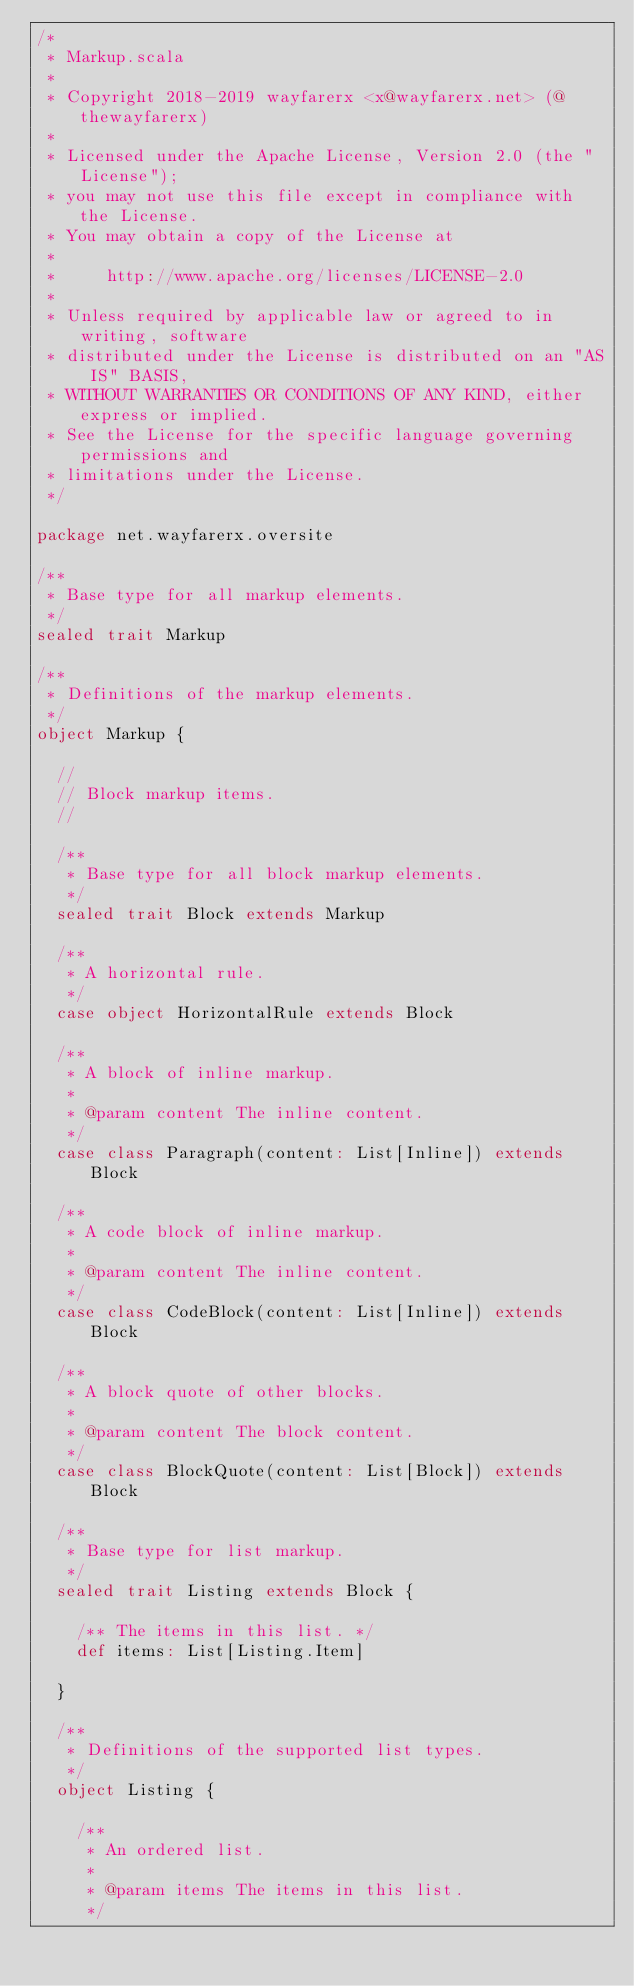<code> <loc_0><loc_0><loc_500><loc_500><_Scala_>/*
 * Markup.scala
 *
 * Copyright 2018-2019 wayfarerx <x@wayfarerx.net> (@thewayfarerx)
 *
 * Licensed under the Apache License, Version 2.0 (the "License");
 * you may not use this file except in compliance with the License.
 * You may obtain a copy of the License at
 *
 *     http://www.apache.org/licenses/LICENSE-2.0
 *
 * Unless required by applicable law or agreed to in writing, software
 * distributed under the License is distributed on an "AS IS" BASIS,
 * WITHOUT WARRANTIES OR CONDITIONS OF ANY KIND, either express or implied.
 * See the License for the specific language governing permissions and
 * limitations under the License.
 */

package net.wayfarerx.oversite

/**
 * Base type for all markup elements.
 */
sealed trait Markup

/**
 * Definitions of the markup elements.
 */
object Markup {

  //
  // Block markup items.
  //

  /**
   * Base type for all block markup elements.
   */
  sealed trait Block extends Markup

  /**
   * A horizontal rule.
   */
  case object HorizontalRule extends Block

  /**
   * A block of inline markup.
   *
   * @param content The inline content.
   */
  case class Paragraph(content: List[Inline]) extends Block

  /**
   * A code block of inline markup.
   *
   * @param content The inline content.
   */
  case class CodeBlock(content: List[Inline]) extends Block

  /**
   * A block quote of other blocks.
   *
   * @param content The block content.
   */
  case class BlockQuote(content: List[Block]) extends Block

  /**
   * Base type for list markup.
   */
  sealed trait Listing extends Block {

    /** The items in this list. */
    def items: List[Listing.Item]

  }

  /**
   * Definitions of the supported list types.
   */
  object Listing {

    /**
     * An ordered list.
     *
     * @param items The items in this list.
     */</code> 